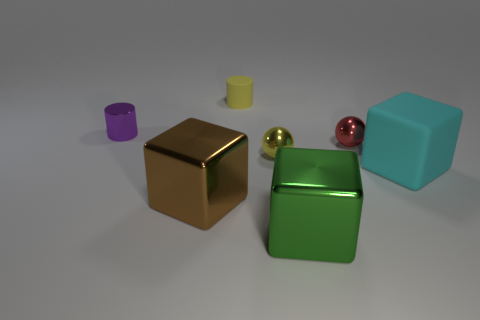Add 3 tiny red balls. How many objects exist? 10 Subtract all blocks. How many objects are left? 4 Subtract all big brown metallic cubes. Subtract all tiny balls. How many objects are left? 4 Add 7 small purple metal objects. How many small purple metal objects are left? 8 Add 4 purple shiny objects. How many purple shiny objects exist? 5 Subtract 0 gray cylinders. How many objects are left? 7 